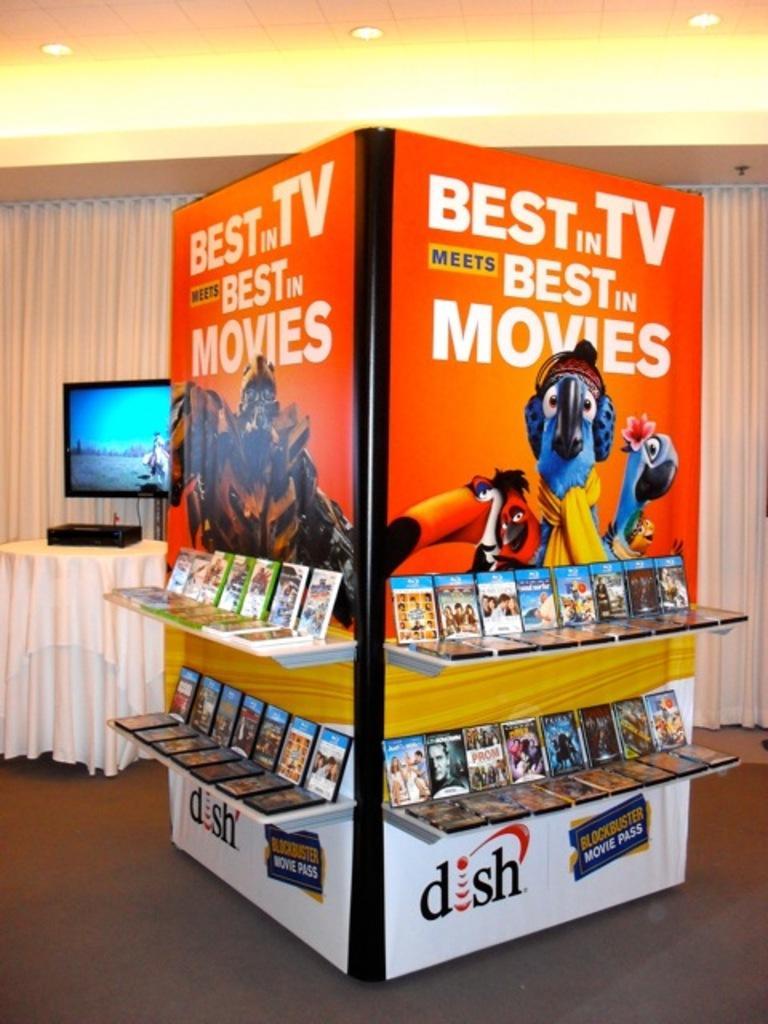Describe this image in one or two sentences. This picture is clicked inside. In the center there is a banner and the shelf on the top of which many number of devices are placed and we can see the text and the the pictures of cartoons are printed on the banner. In the background there is a table on the top of which an electronic device is placed and we can see the curtains, television, roof and the ceiling lights. 